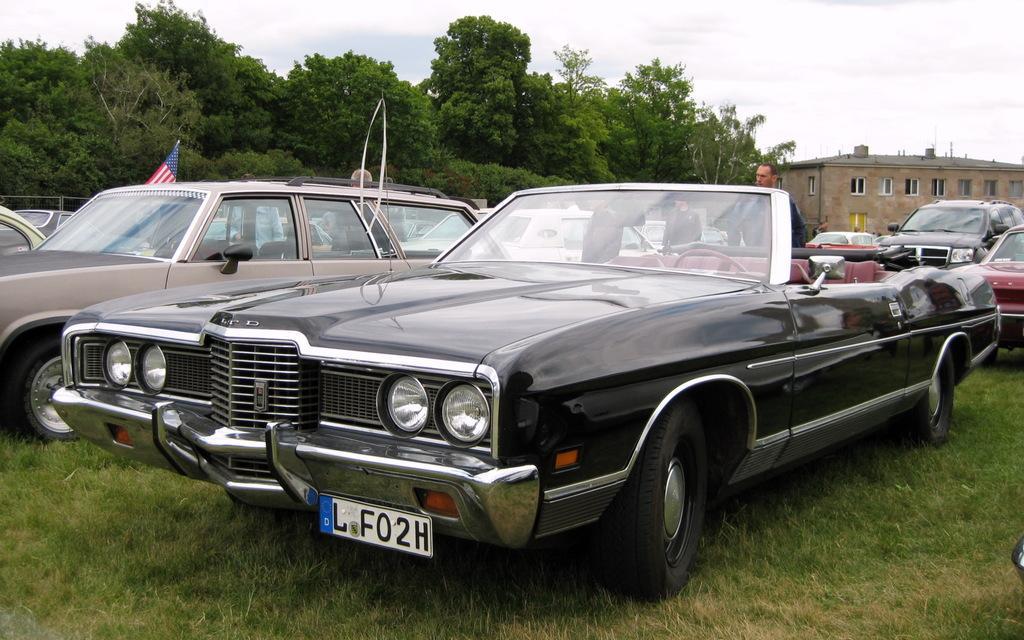Please provide a concise description of this image. In the foreground I can see fleets of cars and a group of people on grass. In the background I can see trees, buildings and the sky. This image is taken may be during a day. 